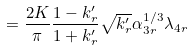Convert formula to latex. <formula><loc_0><loc_0><loc_500><loc_500>= \frac { 2 K } { \pi } \frac { 1 - k ^ { \prime } _ { r } } { 1 + k ^ { \prime } _ { r } } \sqrt { k ^ { \prime } _ { r } } \alpha _ { 3 r } ^ { 1 / 3 } \lambda _ { 4 r }</formula> 